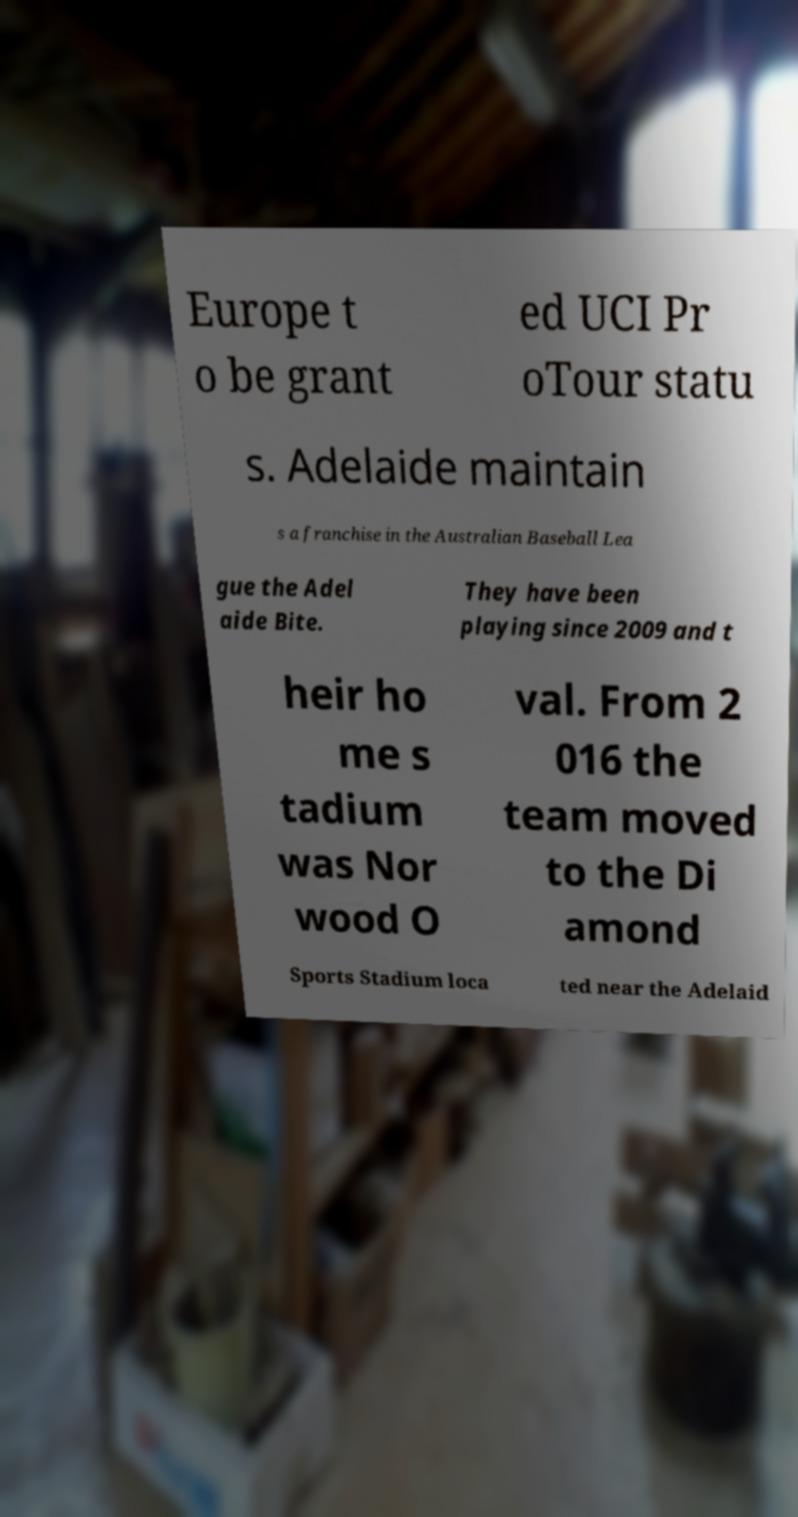Can you accurately transcribe the text from the provided image for me? Europe t o be grant ed UCI Pr oTour statu s. Adelaide maintain s a franchise in the Australian Baseball Lea gue the Adel aide Bite. They have been playing since 2009 and t heir ho me s tadium was Nor wood O val. From 2 016 the team moved to the Di amond Sports Stadium loca ted near the Adelaid 